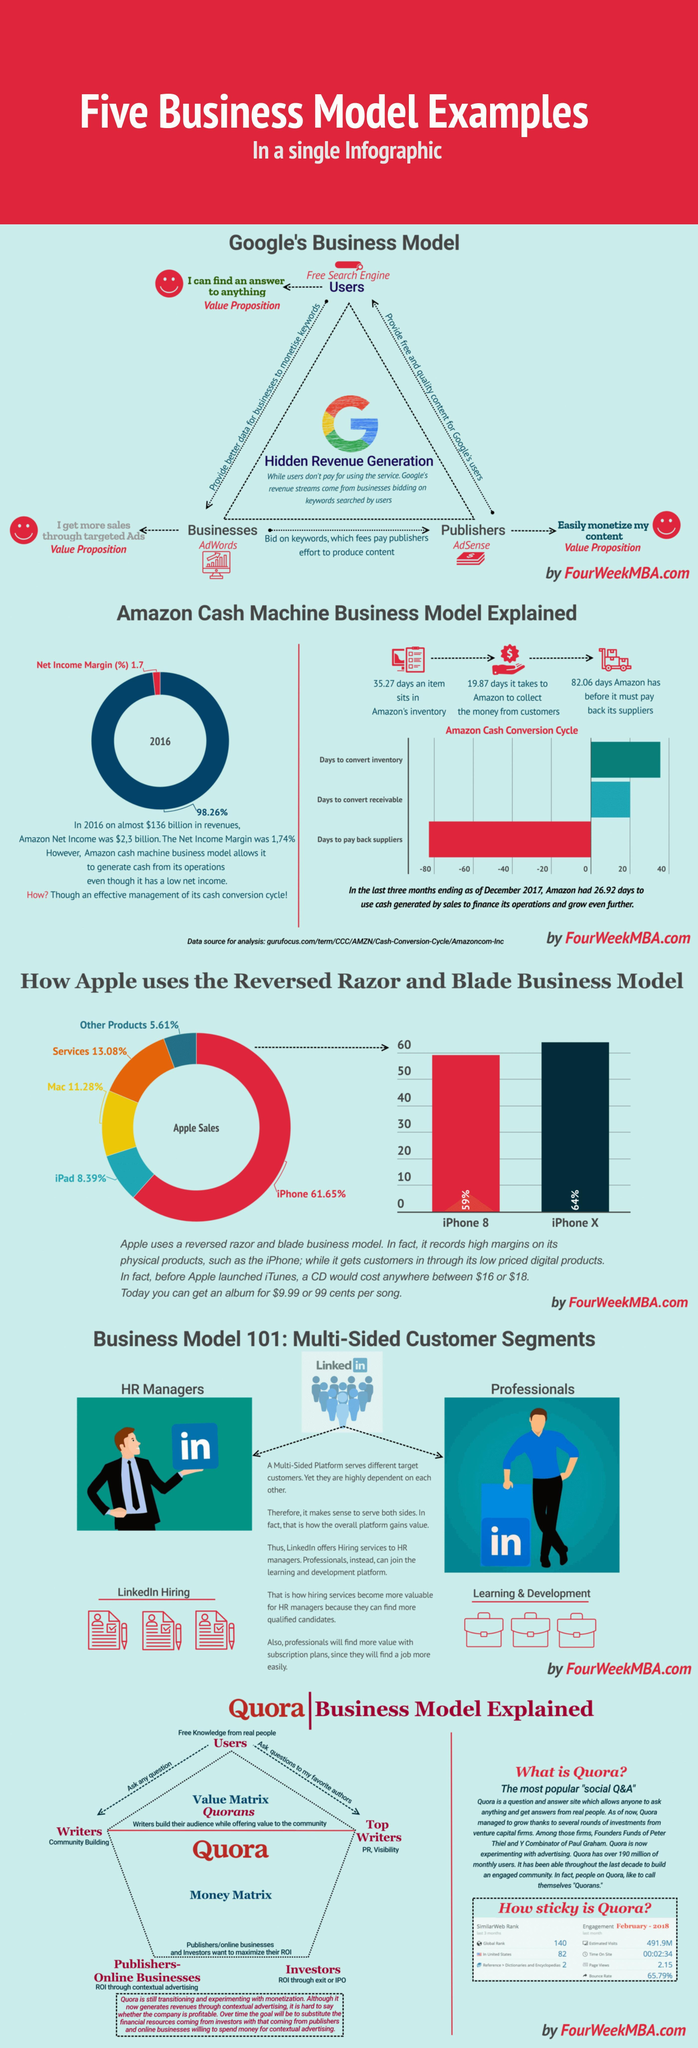How many days an item sits in Amazon's inventory?
Answer the question with a short phrase. 35.27 days How many days were taken by amazon to collect the money from customers? 19.87 days 